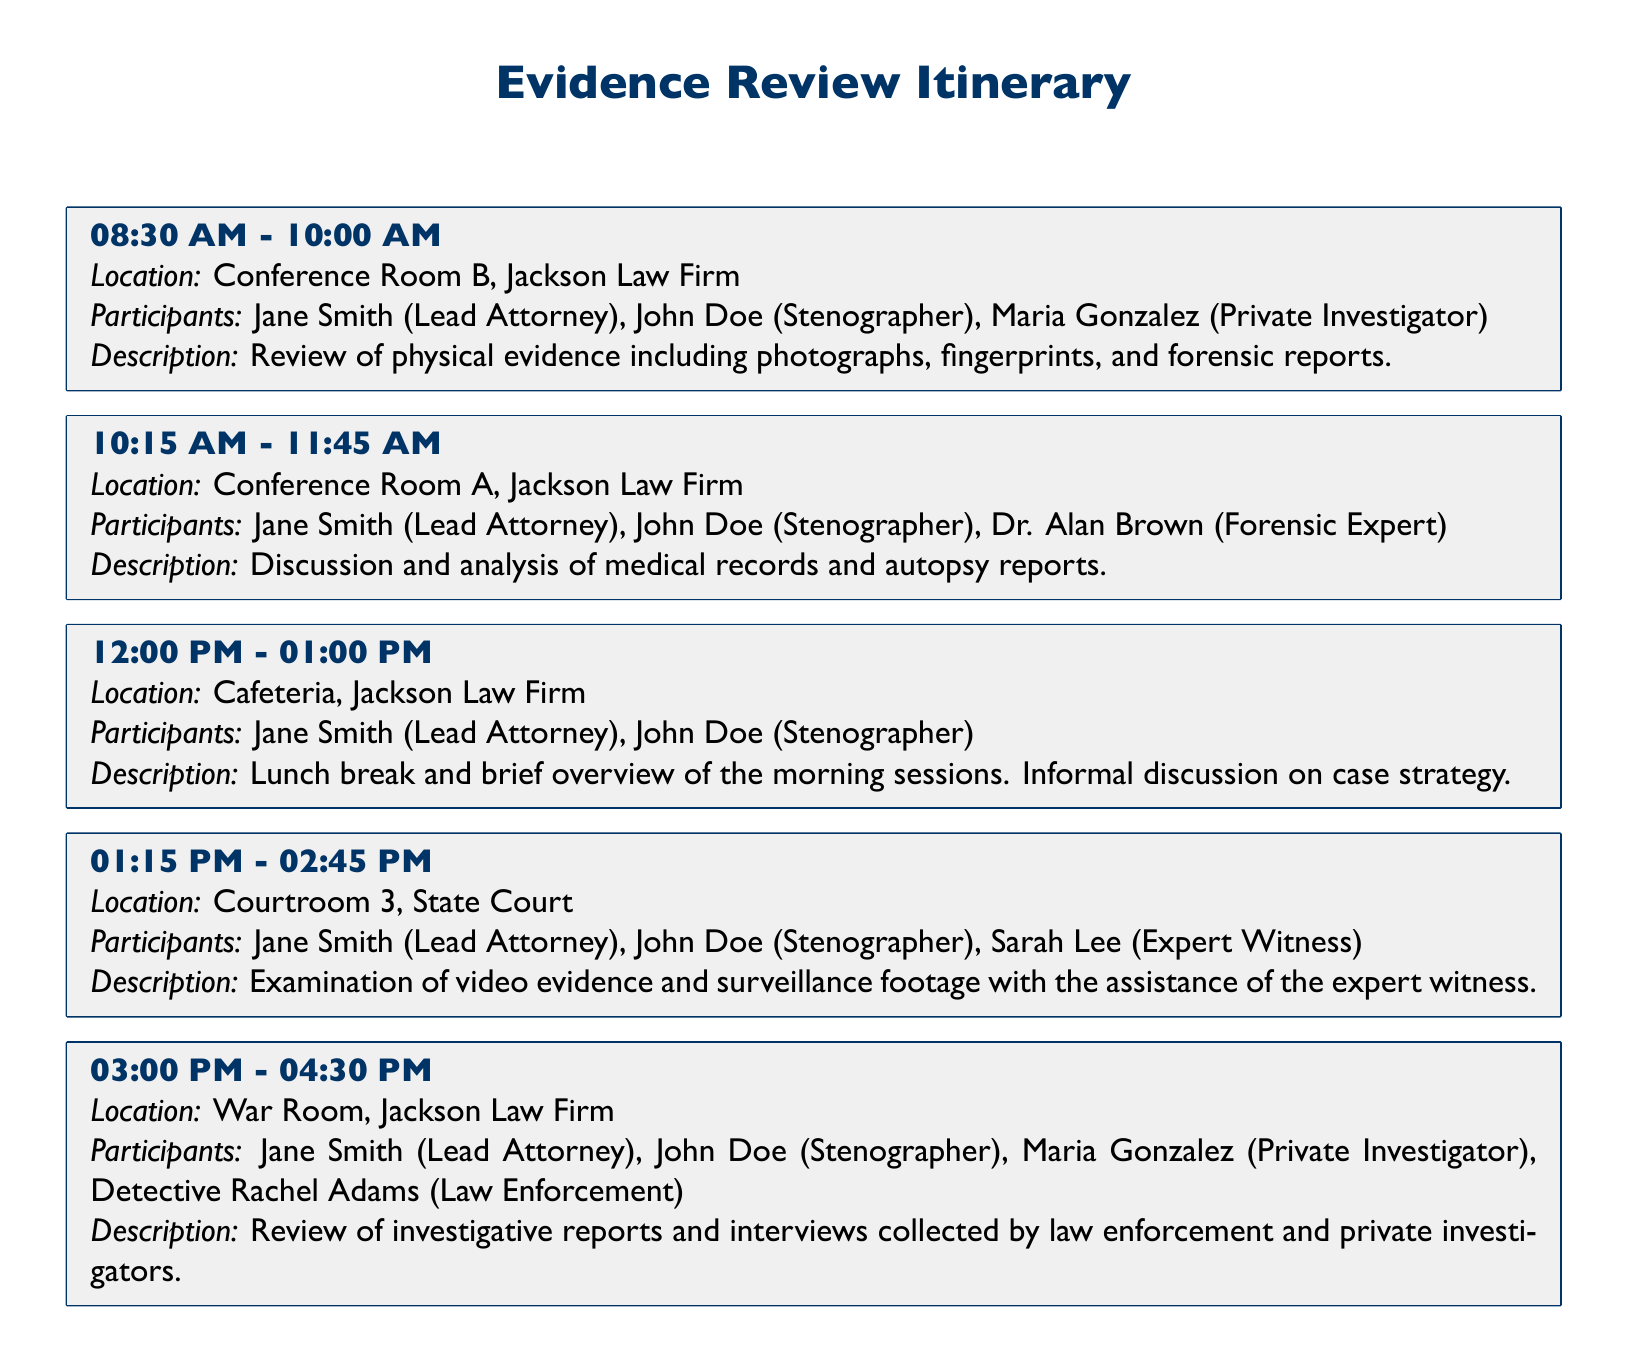what time is the first session scheduled? The first session is scheduled from 08:30 AM to 10:00 AM.
Answer: 08:30 AM - 10:00 AM where is the lunch break taking place? The lunch break is taking place in the Cafeteria at Jackson Law Firm.
Answer: Cafeteria, Jackson Law Firm who are the participants in the video evidence examination session? The participants are Jane Smith, John Doe, and Sarah Lee.
Answer: Jane Smith, John Doe, Sarah Lee how long is the session for reviewing investigative reports? The session for reviewing investigative reports is scheduled for 90 minutes.
Answer: 90 minutes which expert is involved in the medical records discussion? The expert involved in the medical records discussion is Dr. Alan Brown.
Answer: Dr. Alan Brown what is the purpose of the session held at Courtroom 3? The purpose of the session held at Courtroom 3 is to examine video evidence and surveillance footage.
Answer: Examine video evidence and surveillance footage how many locations are mentioned in the Itinerary? There are five locations mentioned in the Itinerary.
Answer: Five locations who is listed as the lead attorney throughout the sessions? The lead attorney listed throughout the sessions is Jane Smith.
Answer: Jane Smith when does the lunch break start? The lunch break starts at 12:00 PM.
Answer: 12:00 PM 